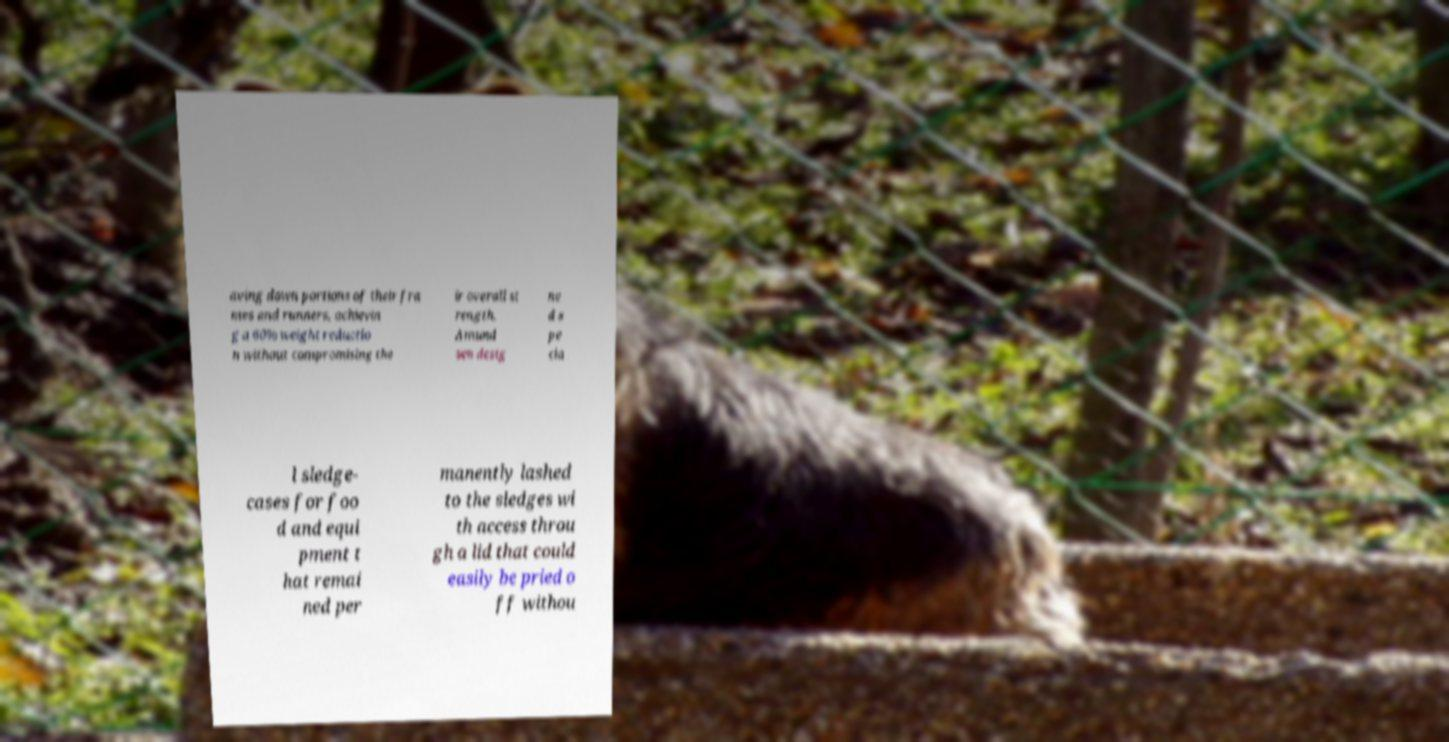There's text embedded in this image that I need extracted. Can you transcribe it verbatim? aving down portions of their fra mes and runners, achievin g a 60% weight reductio n without compromising the ir overall st rength. Amund sen desig ne d s pe cia l sledge- cases for foo d and equi pment t hat remai ned per manently lashed to the sledges wi th access throu gh a lid that could easily be pried o ff withou 